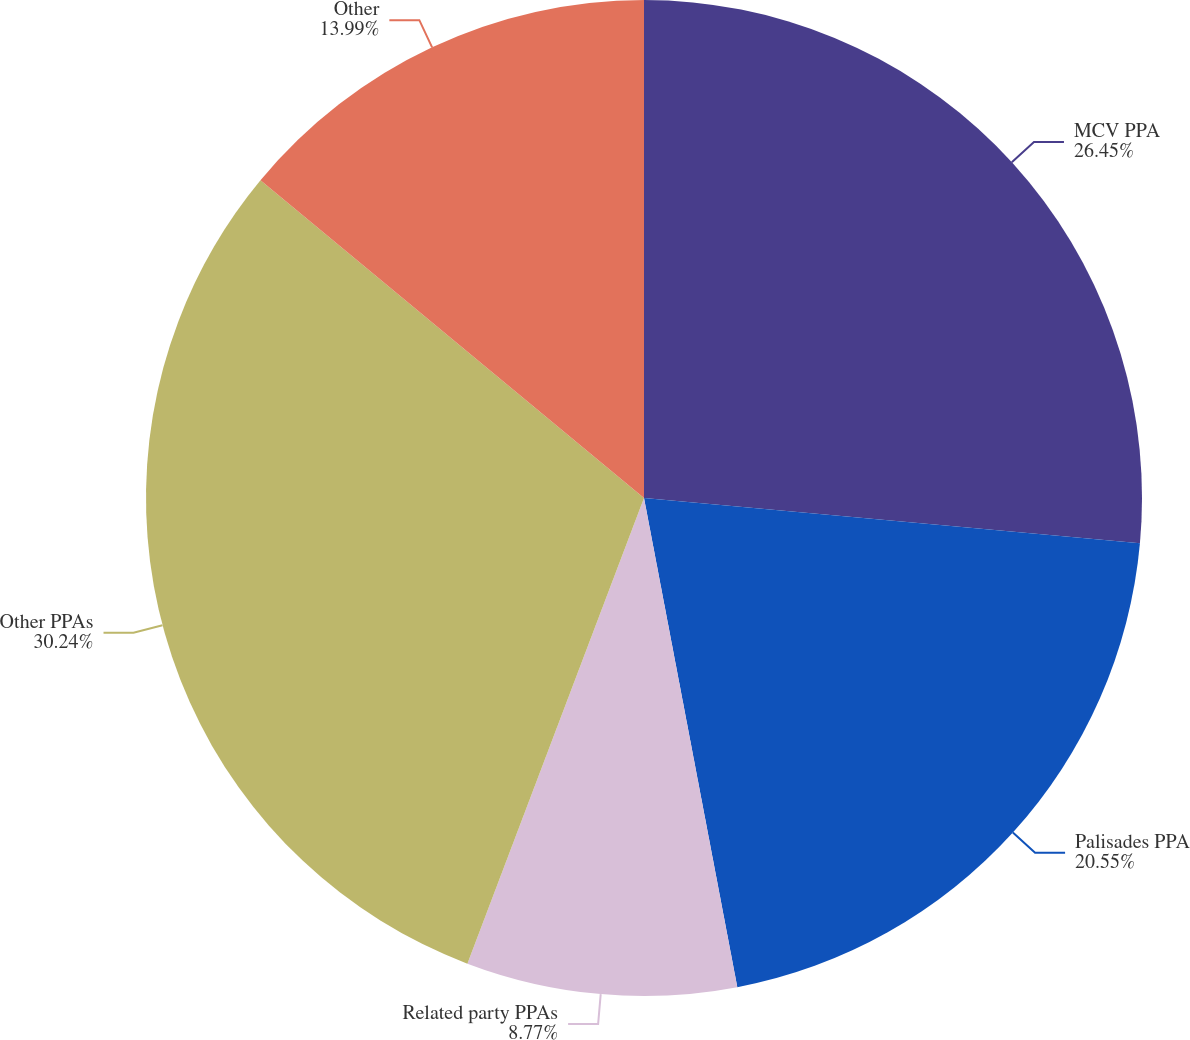Convert chart. <chart><loc_0><loc_0><loc_500><loc_500><pie_chart><fcel>MCV PPA<fcel>Palisades PPA<fcel>Related party PPAs<fcel>Other PPAs<fcel>Other<nl><fcel>26.45%<fcel>20.55%<fcel>8.77%<fcel>30.24%<fcel>13.99%<nl></chart> 